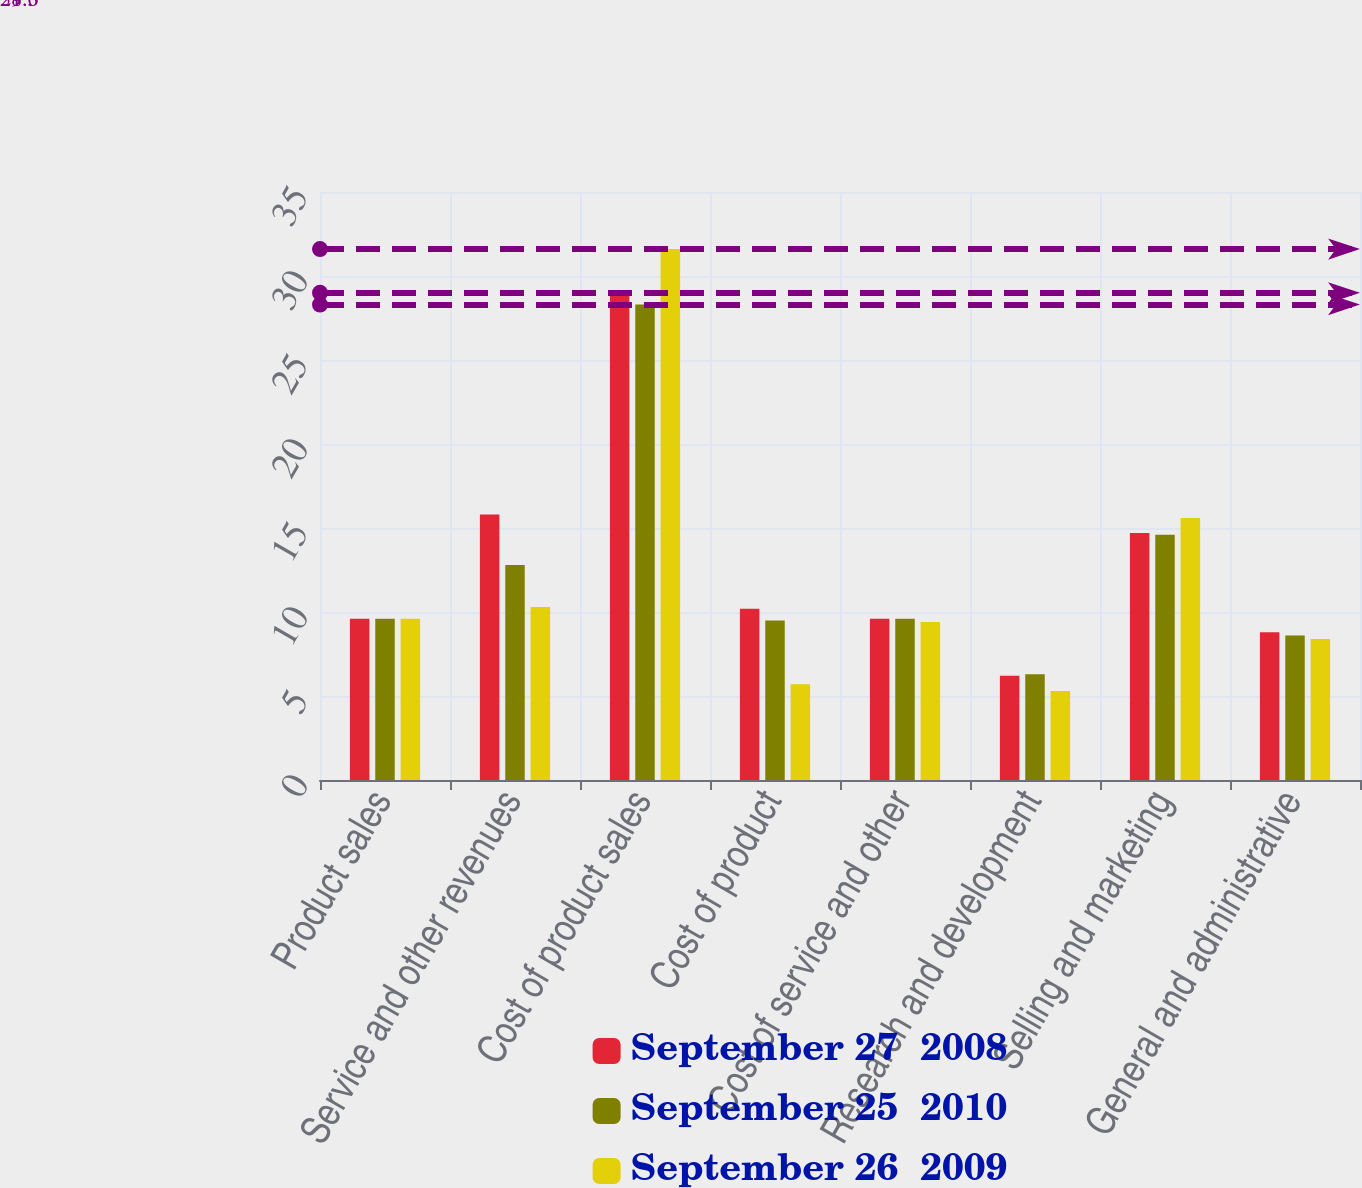Convert chart. <chart><loc_0><loc_0><loc_500><loc_500><stacked_bar_chart><ecel><fcel>Product sales<fcel>Service and other revenues<fcel>Cost of product sales<fcel>Cost of product<fcel>Cost of service and other<fcel>Research and development<fcel>Selling and marketing<fcel>General and administrative<nl><fcel>September 27  2008<fcel>9.6<fcel>15.8<fcel>29<fcel>10.2<fcel>9.6<fcel>6.2<fcel>14.7<fcel>8.8<nl><fcel>September 25  2010<fcel>9.6<fcel>12.8<fcel>28.3<fcel>9.5<fcel>9.6<fcel>6.3<fcel>14.6<fcel>8.6<nl><fcel>September 26  2009<fcel>9.6<fcel>10.3<fcel>31.6<fcel>5.7<fcel>9.4<fcel>5.3<fcel>15.6<fcel>8.4<nl></chart> 